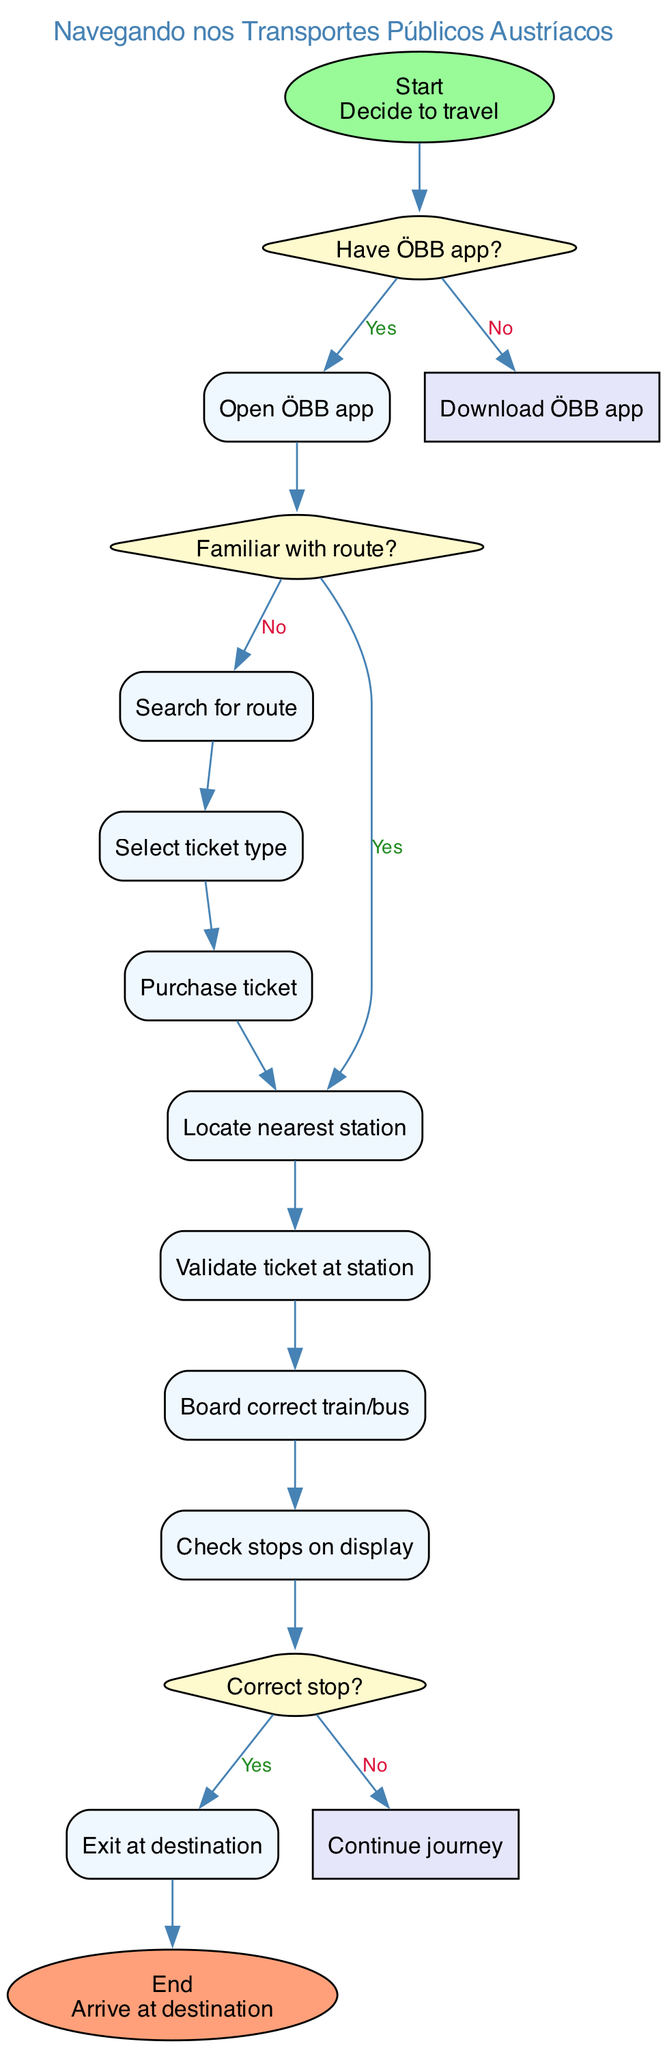What is the starting point of the diagram? The starting point is denoted by the 'start' node, which states "Decide to travel." This is the first action in the flow of navigating the Austrian public transportation system.
Answer: Decide to travel How many decisions are present in the diagram? The diagram contains three decision nodes, each representing a question that leads to different paths depending on the answer (yes or no).
Answer: 3 What is the activity that follows "Open ÖBB app"? After "Open ÖBB app," the next activity is determined by the following decision node which asks, "Familiar with route?" If the answer is 'yes', it goes to "Locate nearest station."
Answer: Locate nearest station What happens if the answer to "Familiar with route?" is 'no'? If the answer is 'no,' it leads to the activity "Search for route," as indicated by the edge connecting the decision node to that activity.
Answer: Search for route What is the final action before reaching the destination? The last action before arriving at the destination is "Exit at destination," which is indicated by the flow of activities leading to the 'end' node.
Answer: Exit at destination If you have the ÖBB app, what is the first activity? If you have the ÖBB app, you directly perform the activity "Open ÖBB app," as indicated by the edge leading from the decision node to that activity.
Answer: Open ÖBB app What is the purpose of the decision nodes in this diagram? The decision nodes serve to direct the flow of activities based on specific questions, determining the path to follow through the public transportation process depending on answers received.
Answer: Direct the flow What activity do you perform after purchasing the ticket? After purchasing the ticket, you proceed to "Locate nearest station," as that is the next activity indicated in the sequence following the ticket purchase.
Answer: Locate nearest station What question do you answer before exiting at the destination? Before exiting at the destination, you answer the question "Correct stop?" which dictates whether to stop or continue the journey.
Answer: Correct stop? 